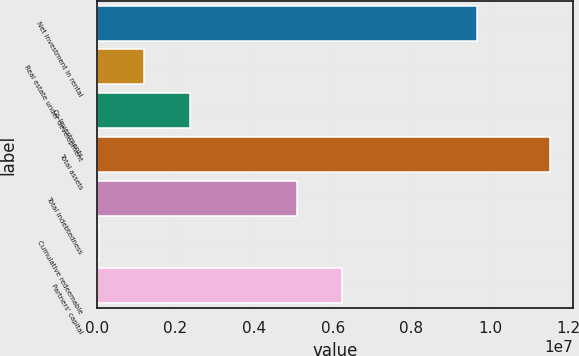Convert chart to OTSL. <chart><loc_0><loc_0><loc_500><loc_500><bar_chart><fcel>Net investment in rental<fcel>Real estate under development<fcel>Co-investments<fcel>Total assets<fcel>Total indebtedness<fcel>Cumulative redeemable<fcel>Partners' capital<nl><fcel>9.67988e+06<fcel>1.21676e+06<fcel>2.36231e+06<fcel>1.15267e+07<fcel>5.08069e+06<fcel>71209<fcel>6.22624e+06<nl></chart> 